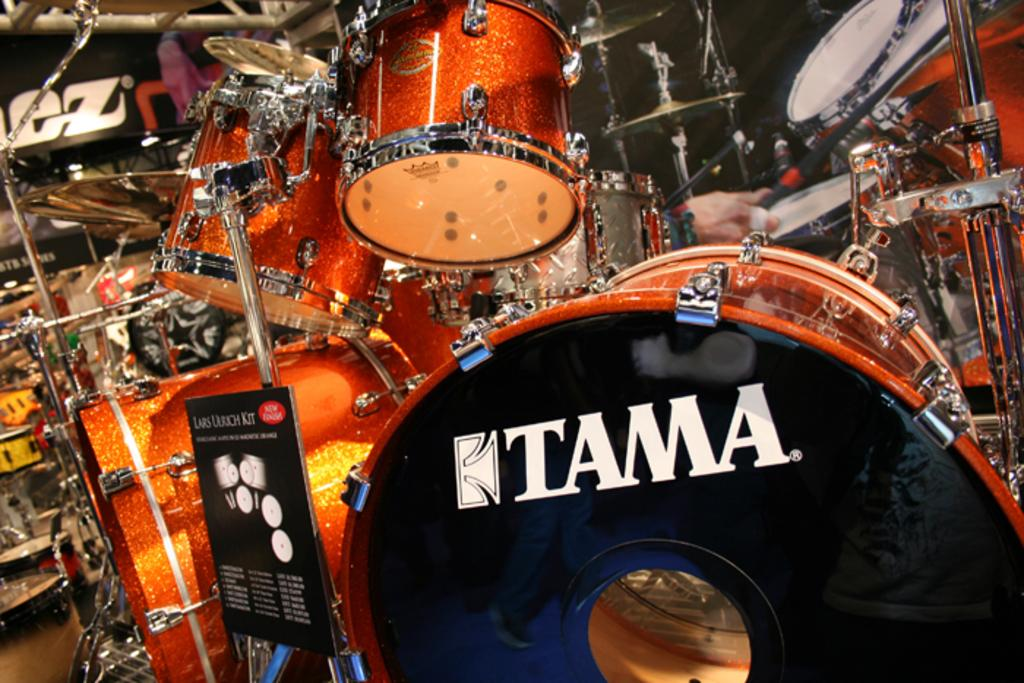What objects are present in the image that are related to music? There are musical instruments in the image. What type of establishment can be seen in the image? There are shops in the image. Can you describe the person's hand in the image? A person's hand holding a stick is visible in the image. What is the condition of the person's stomach in the image? There is no information about the person's stomach in the image, as it is not visible. 